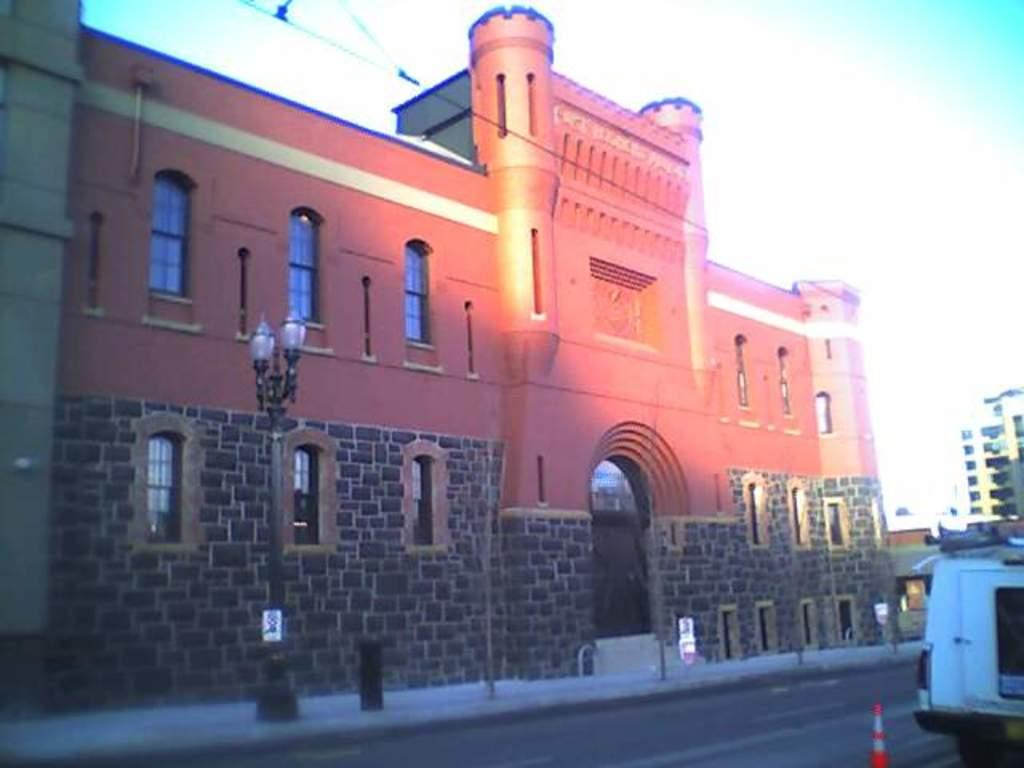What type of pathway is visible in the image? There is a road in the image. What mode of transportation can be seen on the road? There is a vehicle in the image. What is the pedestrian pathway located next to the road? There is a sidewalk in the image. What structures are present alongside the road and sidewalk? There are poles and buildings in the image. What can be seen in the background of the image? The sky is visible in the background of the image. What type of lace is being used to decorate the buildings in the image? There is no lace present on the buildings in the image; they are not decorated with lace. Can you describe the fight between the two vehicles in the image? There is no fight between vehicles in the image; only one vehicle is visible. 